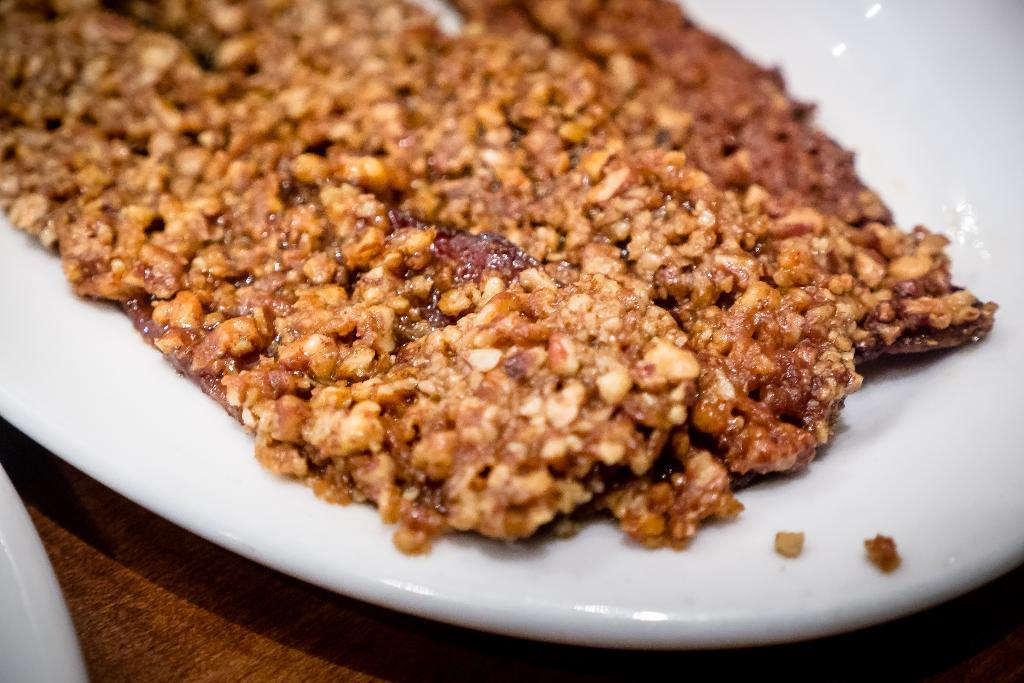What object is present on the plate in the image? There is a food item on the plate in the image. Can you describe the food item on the plate? Unfortunately, the provided facts do not specify the type of food item on the plate. What type of hope can be seen growing on the plate in the image? There is no hope present in the image; it is a plate with a food item on it. 